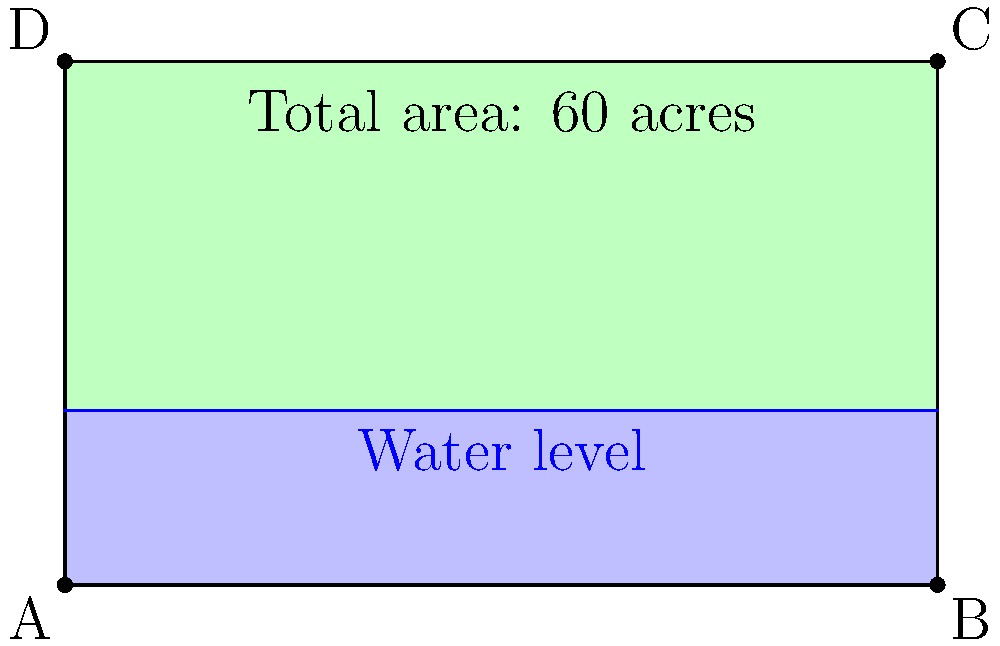A rectangular field measures 10 units by 6 units, representing a total area of 60 acres. The field is partially submerged due to flooding, with the water level reaching 2 units high from the bottom. What percentage of the insured crop area has been damaged by the flood? To calculate the percentage of insured crop damage, we need to follow these steps:

1. Calculate the total area of the field:
   Total area = 60 acres (given in the diagram)

2. Calculate the submerged area:
   Submerged height = 2 units
   Total height = 6 units
   Submerged fraction = $\frac{2}{6} = \frac{1}{3}$
   Submerged area = $\frac{1}{3} \times 60$ acres = 20 acres

3. Calculate the percentage of damaged area:
   Percentage damaged = $\frac{\text{Submerged area}}{\text{Total area}} \times 100\%$
   $= \frac{20}{60} \times 100\%$
   $= \frac{1}{3} \times 100\%$
   $= 33.33\%$ (rounded to two decimal places)

Therefore, 33.33% of the insured crop area has been damaged by the flood.
Answer: 33.33% 